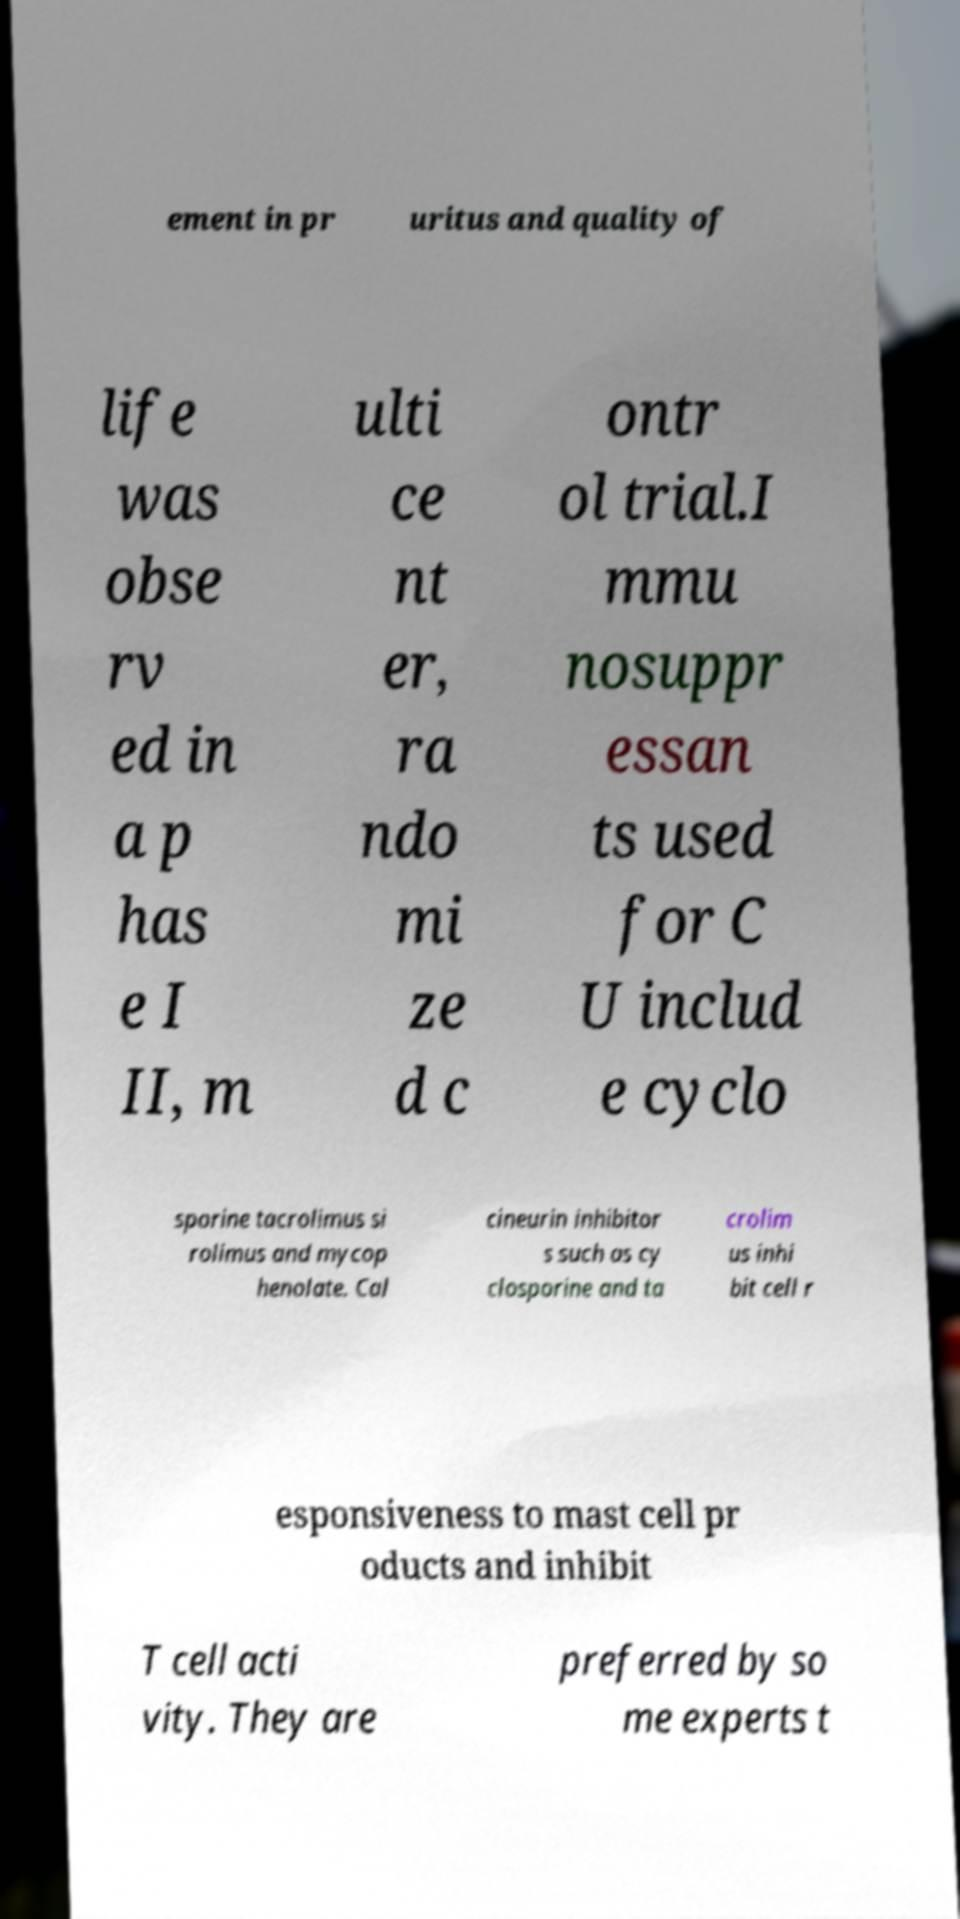Please read and relay the text visible in this image. What does it say? ement in pr uritus and quality of life was obse rv ed in a p has e I II, m ulti ce nt er, ra ndo mi ze d c ontr ol trial.I mmu nosuppr essan ts used for C U includ e cyclo sporine tacrolimus si rolimus and mycop henolate. Cal cineurin inhibitor s such as cy closporine and ta crolim us inhi bit cell r esponsiveness to mast cell pr oducts and inhibit T cell acti vity. They are preferred by so me experts t 